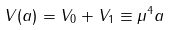Convert formula to latex. <formula><loc_0><loc_0><loc_500><loc_500>V ( a ) = V _ { 0 } + V _ { 1 } \equiv \mu ^ { 4 } a</formula> 